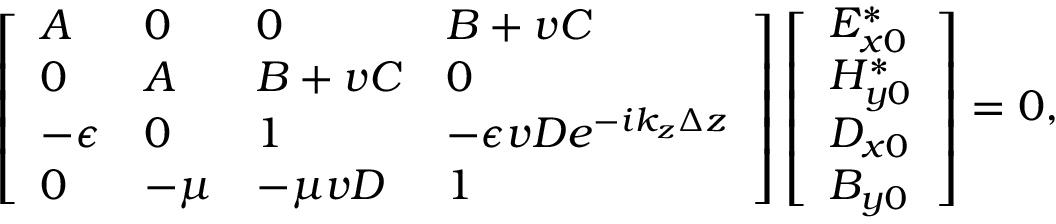Convert formula to latex. <formula><loc_0><loc_0><loc_500><loc_500>\left [ \begin{array} { l l l l } { A } & { 0 } & { 0 } & { B + v C } \\ { 0 } & { A } & { B + v C } & { 0 } \\ { - \epsilon } & { 0 } & { 1 } & { - \epsilon v D e ^ { - i k _ { z } \Delta z } } \\ { 0 } & { - \mu } & { - \mu v D } & { 1 } \end{array} \right ] \left [ \begin{array} { l } { E _ { x 0 } ^ { * } } \\ { H _ { y 0 } ^ { * } } \\ { D _ { x 0 } } \\ { B _ { y 0 } } \end{array} \right ] = 0 ,</formula> 